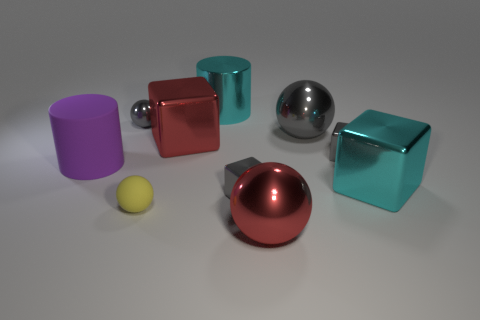There is a cyan object that is left of the cyan metal object to the right of the metallic sphere in front of the tiny matte sphere; what size is it?
Your answer should be very brief. Large. There is a object that is behind the big gray shiny object and in front of the large cyan cylinder; what is its size?
Give a very brief answer. Small. Does the tiny thing that is on the right side of the red metal ball have the same color as the rubber thing in front of the large cyan metal cube?
Your response must be concise. No. There is a small matte ball; how many cyan objects are behind it?
Offer a terse response. 2. There is a tiny object left of the tiny ball that is right of the small metal ball; are there any tiny objects that are behind it?
Your response must be concise. No. What number of gray metal objects are the same size as the yellow matte object?
Offer a very short reply. 3. What material is the big cube right of the metallic ball in front of the tiny yellow thing?
Your response must be concise. Metal. There is a small gray object that is on the right side of the tiny block on the left side of the gray metal ball that is right of the small yellow rubber object; what is its shape?
Your response must be concise. Cube. Does the large thing to the right of the large gray shiny object have the same shape as the big red shiny object that is to the right of the big red metal block?
Give a very brief answer. No. What number of other objects are there of the same material as the purple cylinder?
Offer a terse response. 1. 